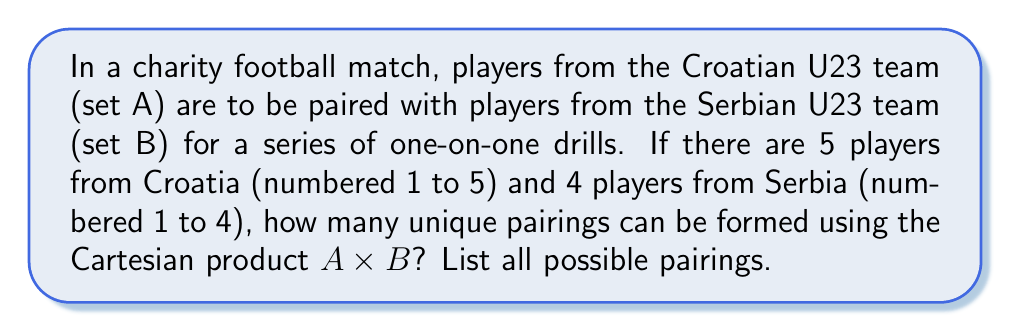Can you solve this math problem? To solve this problem, we need to understand the concept of Cartesian product and apply it to our given sets.

1) First, let's define our sets:
   Set A (Croatian U23 players) = {1, 2, 3, 4, 5}
   Set B (Serbian U23 players) = {1, 2, 3, 4}

2) The Cartesian product $A \times B$ is the set of all ordered pairs (a, b) where a ∈ A and b ∈ B.

3) To find all possible pairings, we need to pair each element of set A with each element of set B.

4) The number of elements in the Cartesian product is given by:
   $|A \times B| = |A| \times |B|$
   Where |A| is the number of elements in set A, and |B| is the number of elements in set B.

5) In this case:
   $|A \times B| = 5 \times 4 = 20$

6) To list all possible pairings, we can systematically pair each Croatian player with each Serbian player:

   (1,1), (1,2), (1,3), (1,4)
   (2,1), (2,2), (2,3), (2,4)
   (3,1), (3,2), (3,3), (3,4)
   (4,1), (4,2), (4,3), (4,4)
   (5,1), (5,2), (5,3), (5,4)

   Where the first number in each pair represents a Croatian player, and the second number represents a Serbian player.
Answer: There are 20 unique pairings. The complete set of pairings is:
$$A \times B = \{(1,1), (1,2), (1,3), (1,4), (2,1), (2,2), (2,3), (2,4), (3,1), (3,2), (3,3), (3,4), (4,1), (4,2), (4,3), (4,4), (5,1), (5,2), (5,3), (5,4)\}$$ 